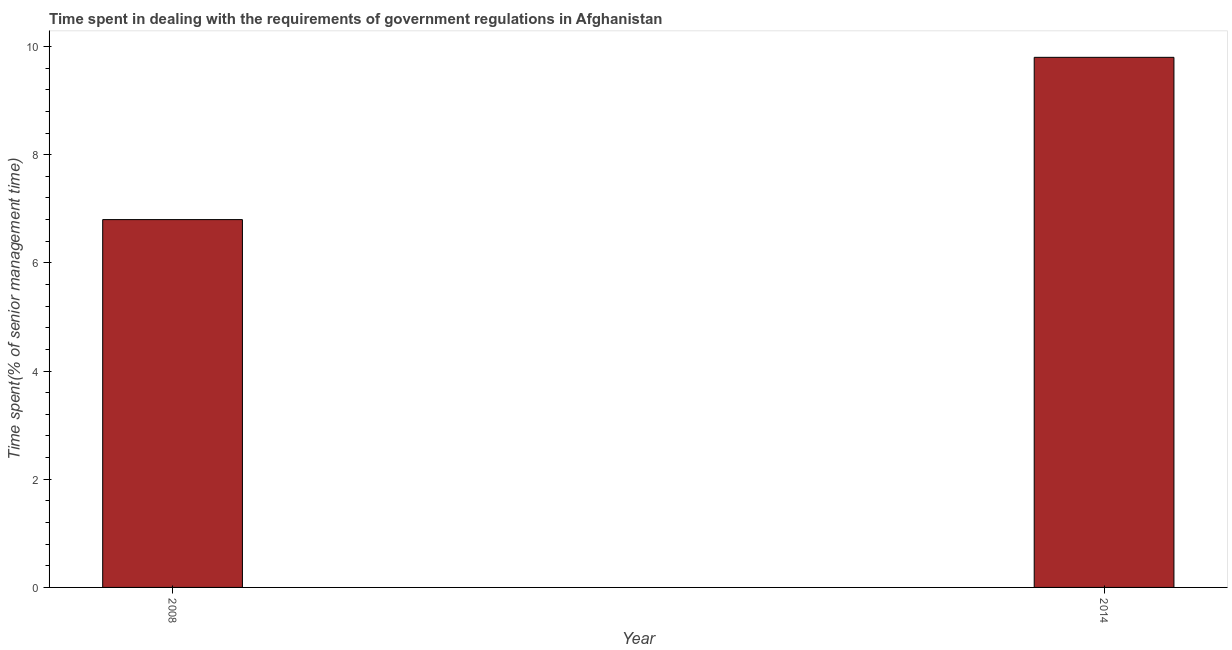Does the graph contain any zero values?
Ensure brevity in your answer.  No. Does the graph contain grids?
Your response must be concise. No. What is the title of the graph?
Make the answer very short. Time spent in dealing with the requirements of government regulations in Afghanistan. What is the label or title of the Y-axis?
Offer a terse response. Time spent(% of senior management time). Across all years, what is the maximum time spent in dealing with government regulations?
Your answer should be compact. 9.8. What is the difference between the time spent in dealing with government regulations in 2008 and 2014?
Provide a succinct answer. -3. What is the average time spent in dealing with government regulations per year?
Ensure brevity in your answer.  8.3. What is the median time spent in dealing with government regulations?
Your answer should be very brief. 8.3. Do a majority of the years between 2014 and 2008 (inclusive) have time spent in dealing with government regulations greater than 8.8 %?
Your response must be concise. No. What is the ratio of the time spent in dealing with government regulations in 2008 to that in 2014?
Offer a terse response. 0.69. Is the time spent in dealing with government regulations in 2008 less than that in 2014?
Offer a terse response. Yes. How many bars are there?
Your answer should be compact. 2. Are the values on the major ticks of Y-axis written in scientific E-notation?
Your response must be concise. No. What is the Time spent(% of senior management time) in 2008?
Your answer should be compact. 6.8. What is the difference between the Time spent(% of senior management time) in 2008 and 2014?
Your answer should be very brief. -3. What is the ratio of the Time spent(% of senior management time) in 2008 to that in 2014?
Your answer should be compact. 0.69. 